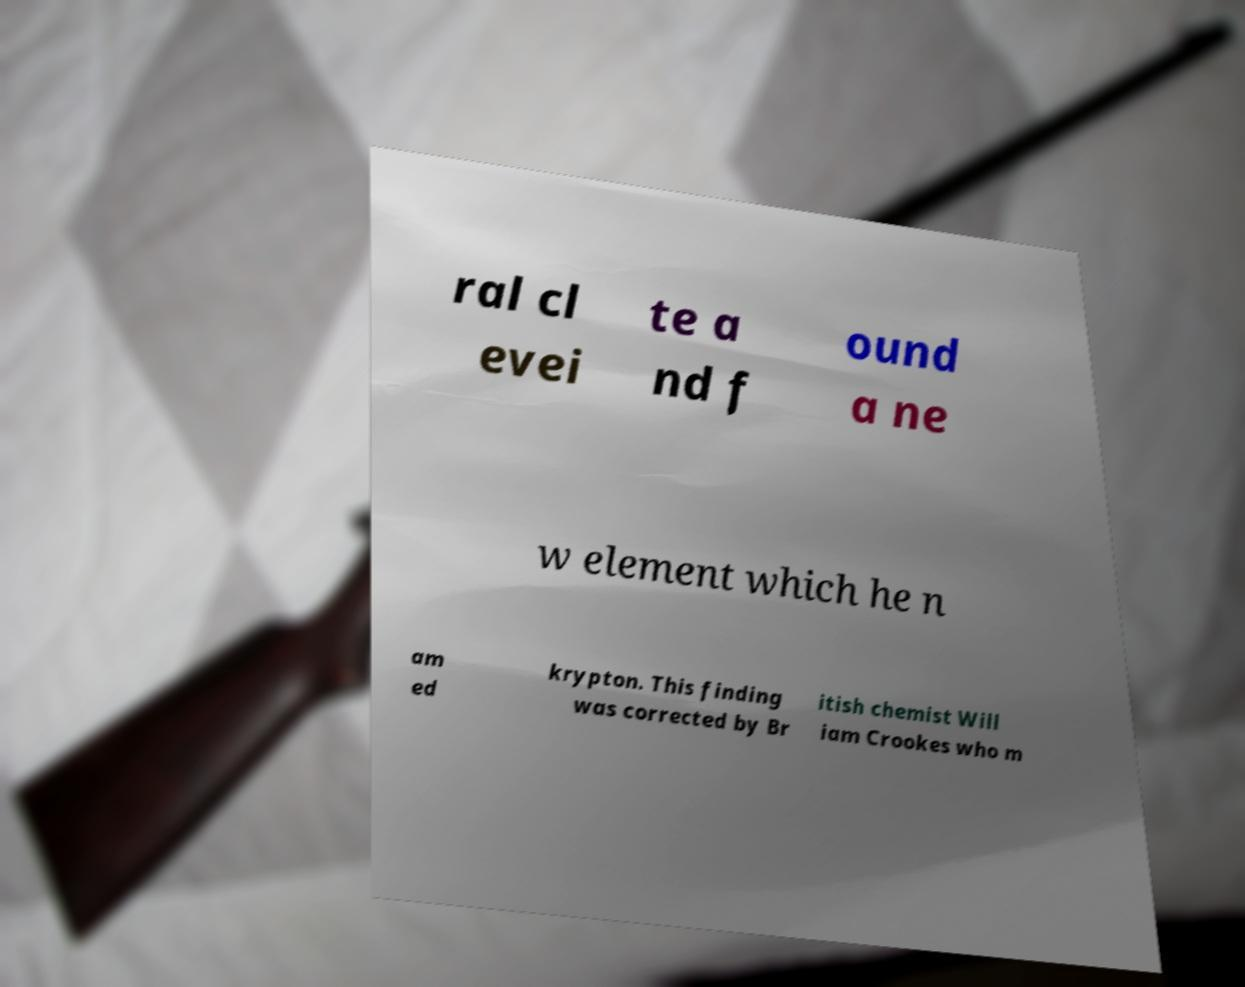For documentation purposes, I need the text within this image transcribed. Could you provide that? ral cl evei te a nd f ound a ne w element which he n am ed krypton. This finding was corrected by Br itish chemist Will iam Crookes who m 